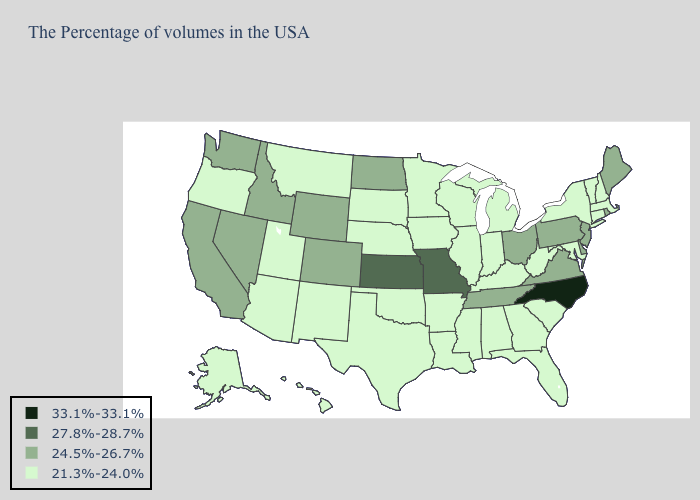Does California have a lower value than North Carolina?
Write a very short answer. Yes. What is the lowest value in the MidWest?
Write a very short answer. 21.3%-24.0%. Name the states that have a value in the range 33.1%-33.1%?
Write a very short answer. North Carolina. Which states have the highest value in the USA?
Give a very brief answer. North Carolina. Among the states that border Alabama , does Tennessee have the highest value?
Concise answer only. Yes. Name the states that have a value in the range 33.1%-33.1%?
Concise answer only. North Carolina. What is the highest value in states that border Kentucky?
Keep it brief. 27.8%-28.7%. What is the value of Maine?
Short answer required. 24.5%-26.7%. What is the value of Connecticut?
Short answer required. 21.3%-24.0%. Name the states that have a value in the range 27.8%-28.7%?
Write a very short answer. Missouri, Kansas. Which states have the highest value in the USA?
Give a very brief answer. North Carolina. Does Illinois have a higher value than Nevada?
Write a very short answer. No. What is the value of South Dakota?
Be succinct. 21.3%-24.0%. What is the value of North Dakota?
Concise answer only. 24.5%-26.7%. What is the value of Florida?
Quick response, please. 21.3%-24.0%. 